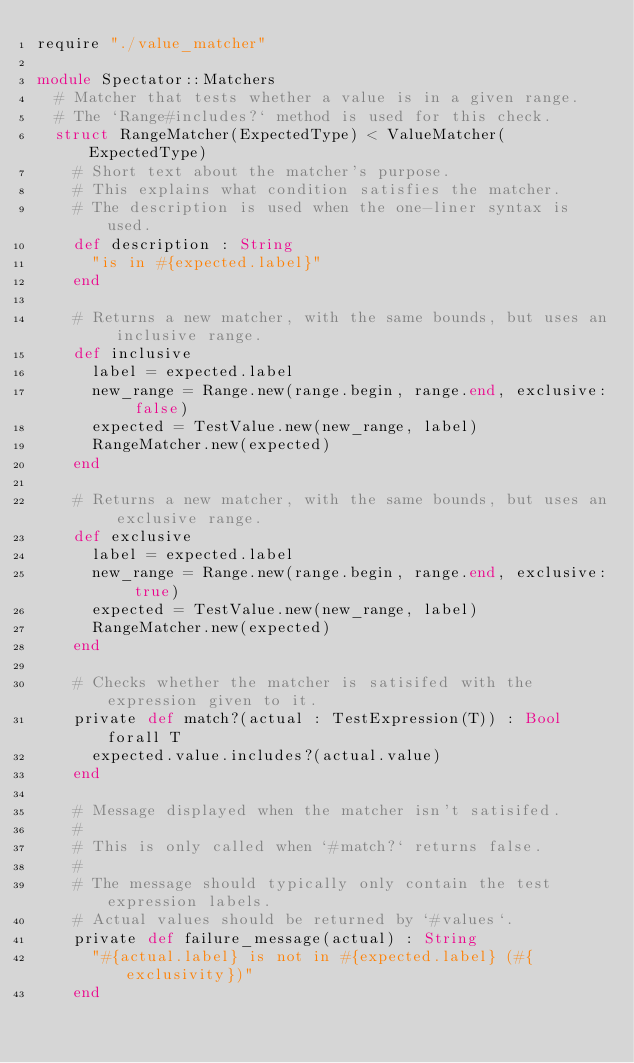<code> <loc_0><loc_0><loc_500><loc_500><_Crystal_>require "./value_matcher"

module Spectator::Matchers
  # Matcher that tests whether a value is in a given range.
  # The `Range#includes?` method is used for this check.
  struct RangeMatcher(ExpectedType) < ValueMatcher(ExpectedType)
    # Short text about the matcher's purpose.
    # This explains what condition satisfies the matcher.
    # The description is used when the one-liner syntax is used.
    def description : String
      "is in #{expected.label}"
    end

    # Returns a new matcher, with the same bounds, but uses an inclusive range.
    def inclusive
      label = expected.label
      new_range = Range.new(range.begin, range.end, exclusive: false)
      expected = TestValue.new(new_range, label)
      RangeMatcher.new(expected)
    end

    # Returns a new matcher, with the same bounds, but uses an exclusive range.
    def exclusive
      label = expected.label
      new_range = Range.new(range.begin, range.end, exclusive: true)
      expected = TestValue.new(new_range, label)
      RangeMatcher.new(expected)
    end

    # Checks whether the matcher is satisifed with the expression given to it.
    private def match?(actual : TestExpression(T)) : Bool forall T
      expected.value.includes?(actual.value)
    end

    # Message displayed when the matcher isn't satisifed.
    #
    # This is only called when `#match?` returns false.
    #
    # The message should typically only contain the test expression labels.
    # Actual values should be returned by `#values`.
    private def failure_message(actual) : String
      "#{actual.label} is not in #{expected.label} (#{exclusivity})"
    end
</code> 